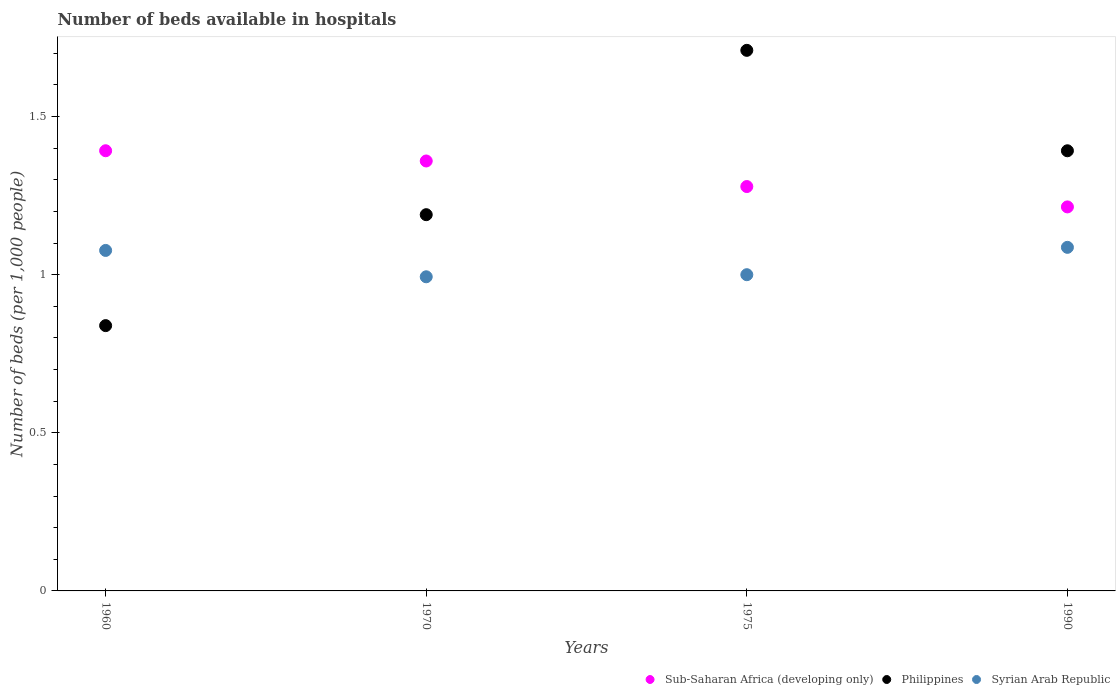What is the number of beds in the hospiatls of in Syrian Arab Republic in 1990?
Provide a short and direct response. 1.09. Across all years, what is the maximum number of beds in the hospiatls of in Syrian Arab Republic?
Provide a short and direct response. 1.09. Across all years, what is the minimum number of beds in the hospiatls of in Philippines?
Your response must be concise. 0.84. In which year was the number of beds in the hospiatls of in Philippines maximum?
Your answer should be very brief. 1975. What is the total number of beds in the hospiatls of in Philippines in the graph?
Provide a succinct answer. 5.13. What is the difference between the number of beds in the hospiatls of in Sub-Saharan Africa (developing only) in 1960 and that in 1970?
Keep it short and to the point. 0.03. What is the difference between the number of beds in the hospiatls of in Sub-Saharan Africa (developing only) in 1970 and the number of beds in the hospiatls of in Philippines in 1990?
Make the answer very short. -0.03. What is the average number of beds in the hospiatls of in Syrian Arab Republic per year?
Offer a very short reply. 1.04. In the year 1970, what is the difference between the number of beds in the hospiatls of in Sub-Saharan Africa (developing only) and number of beds in the hospiatls of in Philippines?
Your response must be concise. 0.17. In how many years, is the number of beds in the hospiatls of in Syrian Arab Republic greater than 1.3?
Provide a succinct answer. 0. What is the ratio of the number of beds in the hospiatls of in Syrian Arab Republic in 1960 to that in 1970?
Provide a short and direct response. 1.08. Is the number of beds in the hospiatls of in Syrian Arab Republic in 1970 less than that in 1975?
Provide a short and direct response. Yes. Is the difference between the number of beds in the hospiatls of in Sub-Saharan Africa (developing only) in 1960 and 1975 greater than the difference between the number of beds in the hospiatls of in Philippines in 1960 and 1975?
Your answer should be very brief. Yes. What is the difference between the highest and the second highest number of beds in the hospiatls of in Syrian Arab Republic?
Give a very brief answer. 0.01. What is the difference between the highest and the lowest number of beds in the hospiatls of in Philippines?
Offer a terse response. 0.87. In how many years, is the number of beds in the hospiatls of in Philippines greater than the average number of beds in the hospiatls of in Philippines taken over all years?
Give a very brief answer. 2. Does the number of beds in the hospiatls of in Sub-Saharan Africa (developing only) monotonically increase over the years?
Provide a short and direct response. No. Is the number of beds in the hospiatls of in Sub-Saharan Africa (developing only) strictly greater than the number of beds in the hospiatls of in Philippines over the years?
Provide a short and direct response. No. Is the number of beds in the hospiatls of in Philippines strictly less than the number of beds in the hospiatls of in Sub-Saharan Africa (developing only) over the years?
Offer a very short reply. No. How many dotlines are there?
Provide a short and direct response. 3. How many years are there in the graph?
Give a very brief answer. 4. Are the values on the major ticks of Y-axis written in scientific E-notation?
Keep it short and to the point. No. Does the graph contain any zero values?
Offer a very short reply. No. How many legend labels are there?
Make the answer very short. 3. How are the legend labels stacked?
Keep it short and to the point. Horizontal. What is the title of the graph?
Your answer should be very brief. Number of beds available in hospitals. Does "Monaco" appear as one of the legend labels in the graph?
Keep it short and to the point. No. What is the label or title of the Y-axis?
Offer a terse response. Number of beds (per 1,0 people). What is the Number of beds (per 1,000 people) of Sub-Saharan Africa (developing only) in 1960?
Your response must be concise. 1.39. What is the Number of beds (per 1,000 people) in Philippines in 1960?
Make the answer very short. 0.84. What is the Number of beds (per 1,000 people) of Syrian Arab Republic in 1960?
Offer a very short reply. 1.08. What is the Number of beds (per 1,000 people) of Sub-Saharan Africa (developing only) in 1970?
Your answer should be compact. 1.36. What is the Number of beds (per 1,000 people) of Philippines in 1970?
Your answer should be very brief. 1.19. What is the Number of beds (per 1,000 people) in Syrian Arab Republic in 1970?
Give a very brief answer. 0.99. What is the Number of beds (per 1,000 people) in Sub-Saharan Africa (developing only) in 1975?
Your answer should be compact. 1.28. What is the Number of beds (per 1,000 people) of Philippines in 1975?
Your response must be concise. 1.71. What is the Number of beds (per 1,000 people) of Sub-Saharan Africa (developing only) in 1990?
Provide a short and direct response. 1.21. What is the Number of beds (per 1,000 people) of Philippines in 1990?
Make the answer very short. 1.39. What is the Number of beds (per 1,000 people) of Syrian Arab Republic in 1990?
Give a very brief answer. 1.09. Across all years, what is the maximum Number of beds (per 1,000 people) of Sub-Saharan Africa (developing only)?
Your answer should be very brief. 1.39. Across all years, what is the maximum Number of beds (per 1,000 people) of Philippines?
Keep it short and to the point. 1.71. Across all years, what is the maximum Number of beds (per 1,000 people) in Syrian Arab Republic?
Your answer should be compact. 1.09. Across all years, what is the minimum Number of beds (per 1,000 people) of Sub-Saharan Africa (developing only)?
Your answer should be very brief. 1.21. Across all years, what is the minimum Number of beds (per 1,000 people) in Philippines?
Offer a very short reply. 0.84. Across all years, what is the minimum Number of beds (per 1,000 people) in Syrian Arab Republic?
Your answer should be very brief. 0.99. What is the total Number of beds (per 1,000 people) of Sub-Saharan Africa (developing only) in the graph?
Give a very brief answer. 5.24. What is the total Number of beds (per 1,000 people) of Philippines in the graph?
Offer a terse response. 5.13. What is the total Number of beds (per 1,000 people) of Syrian Arab Republic in the graph?
Provide a short and direct response. 4.16. What is the difference between the Number of beds (per 1,000 people) in Sub-Saharan Africa (developing only) in 1960 and that in 1970?
Your answer should be very brief. 0.03. What is the difference between the Number of beds (per 1,000 people) in Philippines in 1960 and that in 1970?
Provide a succinct answer. -0.35. What is the difference between the Number of beds (per 1,000 people) in Syrian Arab Republic in 1960 and that in 1970?
Provide a succinct answer. 0.08. What is the difference between the Number of beds (per 1,000 people) in Sub-Saharan Africa (developing only) in 1960 and that in 1975?
Offer a very short reply. 0.11. What is the difference between the Number of beds (per 1,000 people) in Philippines in 1960 and that in 1975?
Make the answer very short. -0.87. What is the difference between the Number of beds (per 1,000 people) in Syrian Arab Republic in 1960 and that in 1975?
Offer a very short reply. 0.08. What is the difference between the Number of beds (per 1,000 people) of Sub-Saharan Africa (developing only) in 1960 and that in 1990?
Your answer should be compact. 0.18. What is the difference between the Number of beds (per 1,000 people) of Philippines in 1960 and that in 1990?
Offer a very short reply. -0.55. What is the difference between the Number of beds (per 1,000 people) of Syrian Arab Republic in 1960 and that in 1990?
Offer a very short reply. -0.01. What is the difference between the Number of beds (per 1,000 people) of Sub-Saharan Africa (developing only) in 1970 and that in 1975?
Your response must be concise. 0.08. What is the difference between the Number of beds (per 1,000 people) of Philippines in 1970 and that in 1975?
Provide a succinct answer. -0.52. What is the difference between the Number of beds (per 1,000 people) in Syrian Arab Republic in 1970 and that in 1975?
Ensure brevity in your answer.  -0.01. What is the difference between the Number of beds (per 1,000 people) of Sub-Saharan Africa (developing only) in 1970 and that in 1990?
Your response must be concise. 0.15. What is the difference between the Number of beds (per 1,000 people) of Philippines in 1970 and that in 1990?
Make the answer very short. -0.2. What is the difference between the Number of beds (per 1,000 people) of Syrian Arab Republic in 1970 and that in 1990?
Your answer should be very brief. -0.09. What is the difference between the Number of beds (per 1,000 people) in Sub-Saharan Africa (developing only) in 1975 and that in 1990?
Provide a succinct answer. 0.06. What is the difference between the Number of beds (per 1,000 people) of Philippines in 1975 and that in 1990?
Give a very brief answer. 0.32. What is the difference between the Number of beds (per 1,000 people) of Syrian Arab Republic in 1975 and that in 1990?
Provide a short and direct response. -0.09. What is the difference between the Number of beds (per 1,000 people) in Sub-Saharan Africa (developing only) in 1960 and the Number of beds (per 1,000 people) in Philippines in 1970?
Offer a terse response. 0.2. What is the difference between the Number of beds (per 1,000 people) of Sub-Saharan Africa (developing only) in 1960 and the Number of beds (per 1,000 people) of Syrian Arab Republic in 1970?
Offer a terse response. 0.4. What is the difference between the Number of beds (per 1,000 people) of Philippines in 1960 and the Number of beds (per 1,000 people) of Syrian Arab Republic in 1970?
Your response must be concise. -0.15. What is the difference between the Number of beds (per 1,000 people) of Sub-Saharan Africa (developing only) in 1960 and the Number of beds (per 1,000 people) of Philippines in 1975?
Your answer should be compact. -0.32. What is the difference between the Number of beds (per 1,000 people) in Sub-Saharan Africa (developing only) in 1960 and the Number of beds (per 1,000 people) in Syrian Arab Republic in 1975?
Make the answer very short. 0.39. What is the difference between the Number of beds (per 1,000 people) of Philippines in 1960 and the Number of beds (per 1,000 people) of Syrian Arab Republic in 1975?
Keep it short and to the point. -0.16. What is the difference between the Number of beds (per 1,000 people) in Sub-Saharan Africa (developing only) in 1960 and the Number of beds (per 1,000 people) in Philippines in 1990?
Provide a succinct answer. 0. What is the difference between the Number of beds (per 1,000 people) of Sub-Saharan Africa (developing only) in 1960 and the Number of beds (per 1,000 people) of Syrian Arab Republic in 1990?
Keep it short and to the point. 0.31. What is the difference between the Number of beds (per 1,000 people) in Philippines in 1960 and the Number of beds (per 1,000 people) in Syrian Arab Republic in 1990?
Your answer should be compact. -0.25. What is the difference between the Number of beds (per 1,000 people) of Sub-Saharan Africa (developing only) in 1970 and the Number of beds (per 1,000 people) of Philippines in 1975?
Make the answer very short. -0.35. What is the difference between the Number of beds (per 1,000 people) in Sub-Saharan Africa (developing only) in 1970 and the Number of beds (per 1,000 people) in Syrian Arab Republic in 1975?
Your response must be concise. 0.36. What is the difference between the Number of beds (per 1,000 people) in Philippines in 1970 and the Number of beds (per 1,000 people) in Syrian Arab Republic in 1975?
Provide a short and direct response. 0.19. What is the difference between the Number of beds (per 1,000 people) in Sub-Saharan Africa (developing only) in 1970 and the Number of beds (per 1,000 people) in Philippines in 1990?
Your answer should be compact. -0.03. What is the difference between the Number of beds (per 1,000 people) of Sub-Saharan Africa (developing only) in 1970 and the Number of beds (per 1,000 people) of Syrian Arab Republic in 1990?
Your response must be concise. 0.27. What is the difference between the Number of beds (per 1,000 people) of Philippines in 1970 and the Number of beds (per 1,000 people) of Syrian Arab Republic in 1990?
Make the answer very short. 0.1. What is the difference between the Number of beds (per 1,000 people) of Sub-Saharan Africa (developing only) in 1975 and the Number of beds (per 1,000 people) of Philippines in 1990?
Ensure brevity in your answer.  -0.11. What is the difference between the Number of beds (per 1,000 people) of Sub-Saharan Africa (developing only) in 1975 and the Number of beds (per 1,000 people) of Syrian Arab Republic in 1990?
Make the answer very short. 0.19. What is the difference between the Number of beds (per 1,000 people) in Philippines in 1975 and the Number of beds (per 1,000 people) in Syrian Arab Republic in 1990?
Provide a short and direct response. 0.62. What is the average Number of beds (per 1,000 people) in Sub-Saharan Africa (developing only) per year?
Ensure brevity in your answer.  1.31. What is the average Number of beds (per 1,000 people) of Philippines per year?
Keep it short and to the point. 1.28. What is the average Number of beds (per 1,000 people) in Syrian Arab Republic per year?
Ensure brevity in your answer.  1.04. In the year 1960, what is the difference between the Number of beds (per 1,000 people) of Sub-Saharan Africa (developing only) and Number of beds (per 1,000 people) of Philippines?
Make the answer very short. 0.55. In the year 1960, what is the difference between the Number of beds (per 1,000 people) in Sub-Saharan Africa (developing only) and Number of beds (per 1,000 people) in Syrian Arab Republic?
Offer a very short reply. 0.32. In the year 1960, what is the difference between the Number of beds (per 1,000 people) in Philippines and Number of beds (per 1,000 people) in Syrian Arab Republic?
Offer a terse response. -0.24. In the year 1970, what is the difference between the Number of beds (per 1,000 people) in Sub-Saharan Africa (developing only) and Number of beds (per 1,000 people) in Philippines?
Your answer should be very brief. 0.17. In the year 1970, what is the difference between the Number of beds (per 1,000 people) in Sub-Saharan Africa (developing only) and Number of beds (per 1,000 people) in Syrian Arab Republic?
Offer a very short reply. 0.37. In the year 1970, what is the difference between the Number of beds (per 1,000 people) in Philippines and Number of beds (per 1,000 people) in Syrian Arab Republic?
Provide a short and direct response. 0.2. In the year 1975, what is the difference between the Number of beds (per 1,000 people) of Sub-Saharan Africa (developing only) and Number of beds (per 1,000 people) of Philippines?
Your answer should be compact. -0.43. In the year 1975, what is the difference between the Number of beds (per 1,000 people) in Sub-Saharan Africa (developing only) and Number of beds (per 1,000 people) in Syrian Arab Republic?
Offer a terse response. 0.28. In the year 1975, what is the difference between the Number of beds (per 1,000 people) of Philippines and Number of beds (per 1,000 people) of Syrian Arab Republic?
Your answer should be compact. 0.71. In the year 1990, what is the difference between the Number of beds (per 1,000 people) of Sub-Saharan Africa (developing only) and Number of beds (per 1,000 people) of Philippines?
Your answer should be very brief. -0.18. In the year 1990, what is the difference between the Number of beds (per 1,000 people) in Sub-Saharan Africa (developing only) and Number of beds (per 1,000 people) in Syrian Arab Republic?
Your answer should be very brief. 0.13. In the year 1990, what is the difference between the Number of beds (per 1,000 people) in Philippines and Number of beds (per 1,000 people) in Syrian Arab Republic?
Provide a short and direct response. 0.31. What is the ratio of the Number of beds (per 1,000 people) in Sub-Saharan Africa (developing only) in 1960 to that in 1970?
Ensure brevity in your answer.  1.02. What is the ratio of the Number of beds (per 1,000 people) of Philippines in 1960 to that in 1970?
Give a very brief answer. 0.71. What is the ratio of the Number of beds (per 1,000 people) in Syrian Arab Republic in 1960 to that in 1970?
Offer a terse response. 1.08. What is the ratio of the Number of beds (per 1,000 people) in Sub-Saharan Africa (developing only) in 1960 to that in 1975?
Your answer should be compact. 1.09. What is the ratio of the Number of beds (per 1,000 people) of Philippines in 1960 to that in 1975?
Provide a succinct answer. 0.49. What is the ratio of the Number of beds (per 1,000 people) of Syrian Arab Republic in 1960 to that in 1975?
Give a very brief answer. 1.08. What is the ratio of the Number of beds (per 1,000 people) of Sub-Saharan Africa (developing only) in 1960 to that in 1990?
Provide a succinct answer. 1.15. What is the ratio of the Number of beds (per 1,000 people) in Philippines in 1960 to that in 1990?
Give a very brief answer. 0.6. What is the ratio of the Number of beds (per 1,000 people) of Syrian Arab Republic in 1960 to that in 1990?
Offer a very short reply. 0.99. What is the ratio of the Number of beds (per 1,000 people) in Sub-Saharan Africa (developing only) in 1970 to that in 1975?
Give a very brief answer. 1.06. What is the ratio of the Number of beds (per 1,000 people) of Philippines in 1970 to that in 1975?
Your response must be concise. 0.7. What is the ratio of the Number of beds (per 1,000 people) in Syrian Arab Republic in 1970 to that in 1975?
Your answer should be compact. 0.99. What is the ratio of the Number of beds (per 1,000 people) of Sub-Saharan Africa (developing only) in 1970 to that in 1990?
Your answer should be very brief. 1.12. What is the ratio of the Number of beds (per 1,000 people) in Philippines in 1970 to that in 1990?
Make the answer very short. 0.85. What is the ratio of the Number of beds (per 1,000 people) in Syrian Arab Republic in 1970 to that in 1990?
Your answer should be compact. 0.91. What is the ratio of the Number of beds (per 1,000 people) in Sub-Saharan Africa (developing only) in 1975 to that in 1990?
Make the answer very short. 1.05. What is the ratio of the Number of beds (per 1,000 people) in Philippines in 1975 to that in 1990?
Your response must be concise. 1.23. What is the ratio of the Number of beds (per 1,000 people) in Syrian Arab Republic in 1975 to that in 1990?
Offer a terse response. 0.92. What is the difference between the highest and the second highest Number of beds (per 1,000 people) of Sub-Saharan Africa (developing only)?
Your answer should be compact. 0.03. What is the difference between the highest and the second highest Number of beds (per 1,000 people) of Philippines?
Offer a very short reply. 0.32. What is the difference between the highest and the second highest Number of beds (per 1,000 people) in Syrian Arab Republic?
Your answer should be very brief. 0.01. What is the difference between the highest and the lowest Number of beds (per 1,000 people) in Sub-Saharan Africa (developing only)?
Make the answer very short. 0.18. What is the difference between the highest and the lowest Number of beds (per 1,000 people) of Philippines?
Your response must be concise. 0.87. What is the difference between the highest and the lowest Number of beds (per 1,000 people) in Syrian Arab Republic?
Offer a terse response. 0.09. 